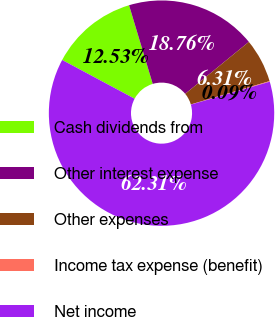Convert chart to OTSL. <chart><loc_0><loc_0><loc_500><loc_500><pie_chart><fcel>Cash dividends from<fcel>Other interest expense<fcel>Other expenses<fcel>Income tax expense (benefit)<fcel>Net income<nl><fcel>12.53%<fcel>18.76%<fcel>6.31%<fcel>0.09%<fcel>62.32%<nl></chart> 